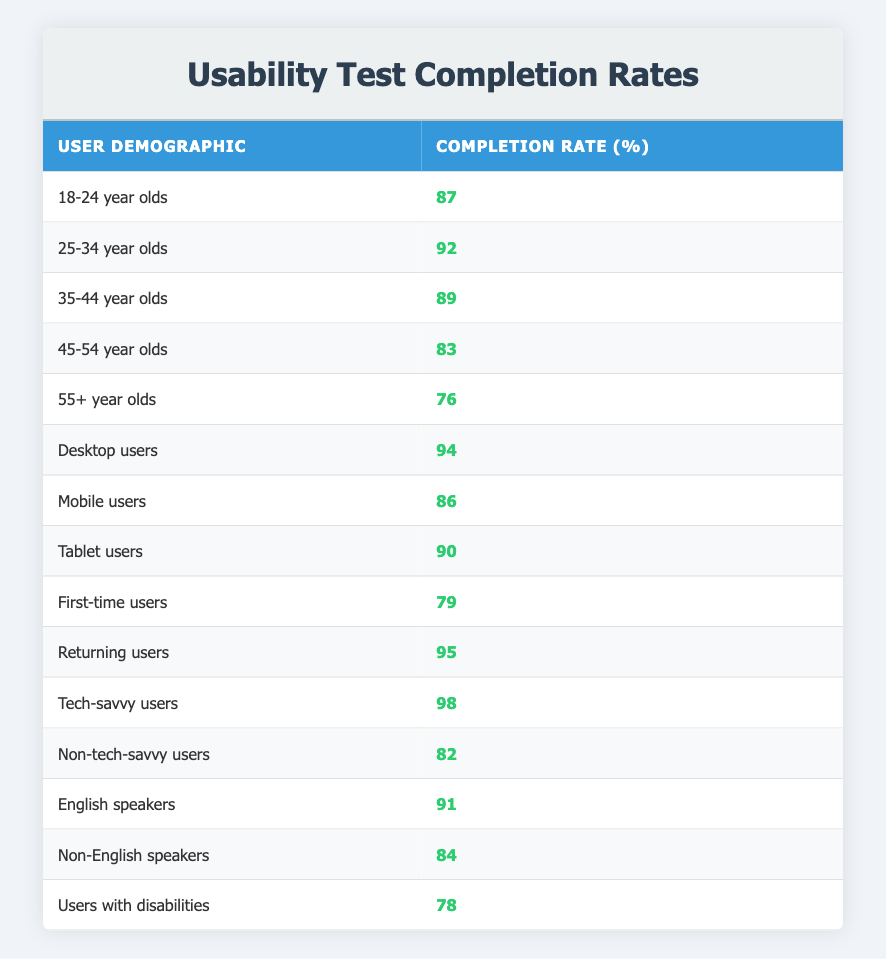What is the completion rate for 18-24 year olds? The completion rate for 18-24 year olds is directly listed in the table under the corresponding demographic. It shows a value of 87%.
Answer: 87% Which user demographic has the highest completion rate? By examining the table, the highest completion rate is for tech-savvy users, which is 98%.
Answer: 98% What is the average completion rate for users aged 35-54? The completion rates for this age range are 89% (35-44 years) and 83% (45-54 years). To find the average, you sum these values: 89 + 83 = 172, and then divide by 2 for the average: 172 / 2 = 86.
Answer: 86% Do mobile users have a higher completion rate than users with disabilities? The completion rate for mobile users is 86%, while for users with disabilities it is 78%. Since 86% is greater than 78%, the answer is yes.
Answer: Yes What is the difference in completion rates between first-time users and returning users? The completion rate for first-time users is 79%, and for returning users, it is 95%. To find the difference, subtract the two values: 95 - 79 = 16.
Answer: 16 What percentage of non-English speakers completed the usability test? The table shows that the completion rate for non-English speakers is 84%.
Answer: 84% Is the completion rate for desktop users lower than the average of all user demographics? The completion rate for desktop users is 94%. To determine if this is lower than the average of all demographics, you must first calculate the average. Adding all completion rates gives a total of 1384% for all demographics (sum of the completion rates in the table) and dividing by 15 (the number of demographic categories) results in an average of approximately 92.27%. Since 94% is higher than this average, the answer is no.
Answer: No Which demographic has a completion rate closest to the overall average of 92.27%? Comparing the completion rates of each demographic to the overall average, the closest values are 92% (25-34 year olds) and 90% (tablet users). Since 92% is closer to 92.27% than 90%, it is the answer.
Answer: 92% What is the completion rate for non-tech-savvy users? The completion rate for non-tech-savvy users is stated directly in the table as 82%.
Answer: 82% 